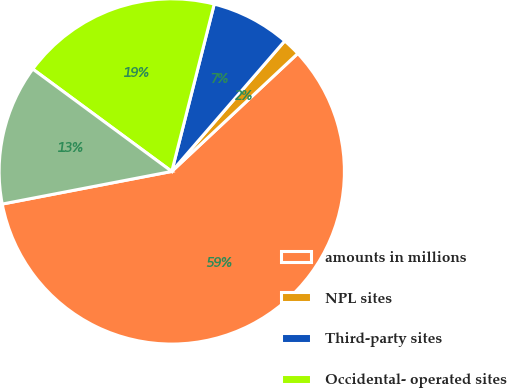<chart> <loc_0><loc_0><loc_500><loc_500><pie_chart><fcel>amounts in millions<fcel>NPL sites<fcel>Third-party sites<fcel>Occidental- operated sites<fcel>Closed or non- operated<nl><fcel>58.95%<fcel>1.67%<fcel>7.4%<fcel>18.85%<fcel>13.13%<nl></chart> 